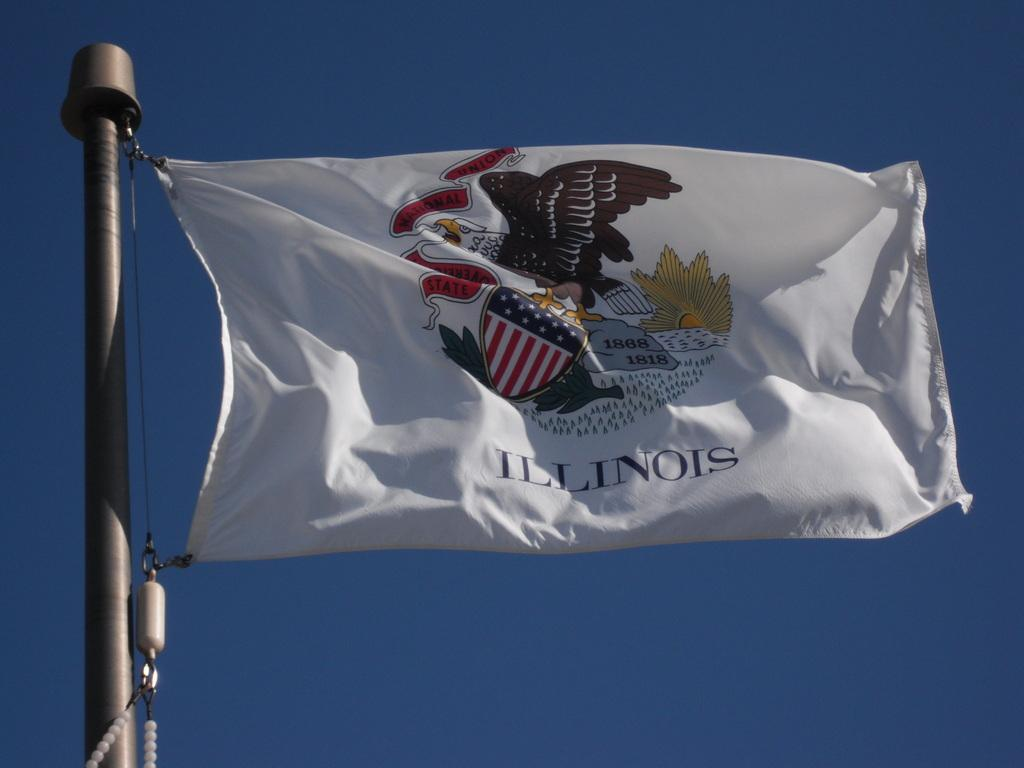What color is the flag in the image? The flag in the image is white. What is the flag attached to? The flag is attached to a silver color pole. What is unique about the pole? The pole has a thread. What can be seen in the background of the image? There is a blue color sky in the background of the image. What type of wool is used to make the flag in the image? There is no mention of wool in the image or the provided facts. 